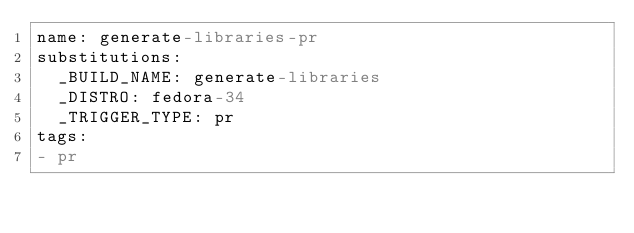Convert code to text. <code><loc_0><loc_0><loc_500><loc_500><_YAML_>name: generate-libraries-pr
substitutions:
  _BUILD_NAME: generate-libraries
  _DISTRO: fedora-34
  _TRIGGER_TYPE: pr
tags:
- pr
</code> 